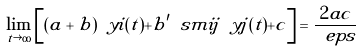<formula> <loc_0><loc_0><loc_500><loc_500>\lim _ { t \rightarrow \infty } \left [ ( a + b ) \ y i ( t ) + b ^ { \prime } \ s m i j \ y j ( t ) + c \right ] = \frac { 2 a c } { \ e p s }</formula> 